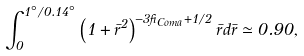Convert formula to latex. <formula><loc_0><loc_0><loc_500><loc_500>\int _ { 0 } ^ { 1 ^ { \circ } / 0 . 1 4 ^ { \circ } } \left ( 1 + \bar { r } ^ { 2 } \right ) ^ { - 3 \beta _ { C o m a } + 1 / 2 } \bar { r } d \bar { r } \simeq 0 . 9 0 ,</formula> 